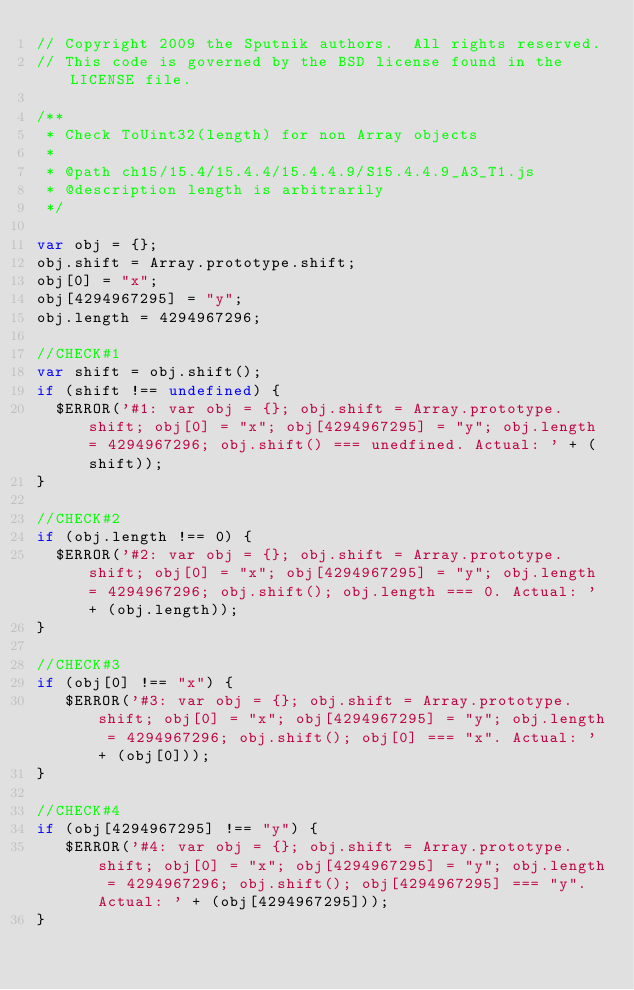<code> <loc_0><loc_0><loc_500><loc_500><_JavaScript_>// Copyright 2009 the Sputnik authors.  All rights reserved.
// This code is governed by the BSD license found in the LICENSE file.

/**
 * Check ToUint32(length) for non Array objects
 *
 * @path ch15/15.4/15.4.4/15.4.4.9/S15.4.4.9_A3_T1.js
 * @description length is arbitrarily
 */

var obj = {};
obj.shift = Array.prototype.shift;
obj[0] = "x";
obj[4294967295] = "y";
obj.length = 4294967296;

//CHECK#1
var shift = obj.shift();
if (shift !== undefined) {
  $ERROR('#1: var obj = {}; obj.shift = Array.prototype.shift; obj[0] = "x"; obj[4294967295] = "y"; obj.length = 4294967296; obj.shift() === unedfined. Actual: ' + (shift));
}

//CHECK#2
if (obj.length !== 0) {
  $ERROR('#2: var obj = {}; obj.shift = Array.prototype.shift; obj[0] = "x"; obj[4294967295] = "y"; obj.length = 4294967296; obj.shift(); obj.length === 0. Actual: ' + (obj.length));
}

//CHECK#3
if (obj[0] !== "x") {
   $ERROR('#3: var obj = {}; obj.shift = Array.prototype.shift; obj[0] = "x"; obj[4294967295] = "y"; obj.length = 4294967296; obj.shift(); obj[0] === "x". Actual: ' + (obj[0]));
}  

//CHECK#4
if (obj[4294967295] !== "y") {
   $ERROR('#4: var obj = {}; obj.shift = Array.prototype.shift; obj[0] = "x"; obj[4294967295] = "y"; obj.length = 4294967296; obj.shift(); obj[4294967295] === "y". Actual: ' + (obj[4294967295]));
}  

</code> 